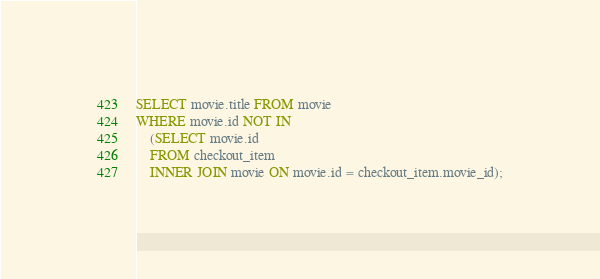<code> <loc_0><loc_0><loc_500><loc_500><_SQL_>SELECT movie.title FROM movie
WHERE movie.id NOT IN
    (SELECT movie.id
    FROM checkout_item
    INNER JOIN movie ON movie.id = checkout_item.movie_id);
</code> 